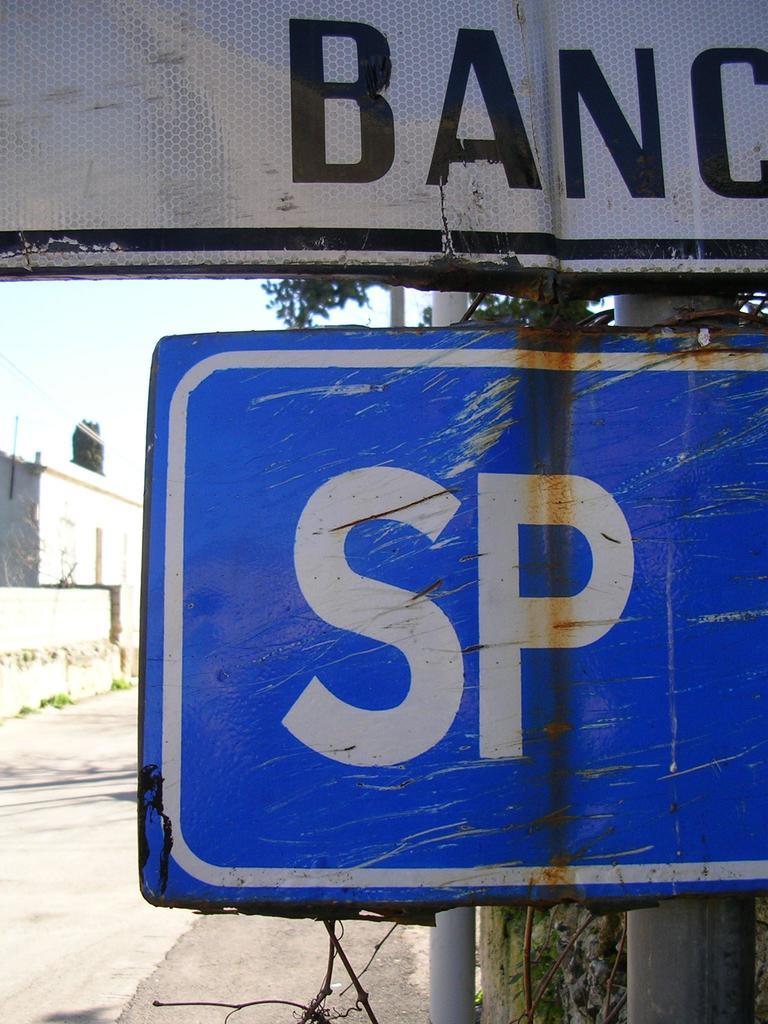What two letters are shown on the blue sign?
Make the answer very short. Sp. What letters are shown on the white sign?
Ensure brevity in your answer.  Banc. 